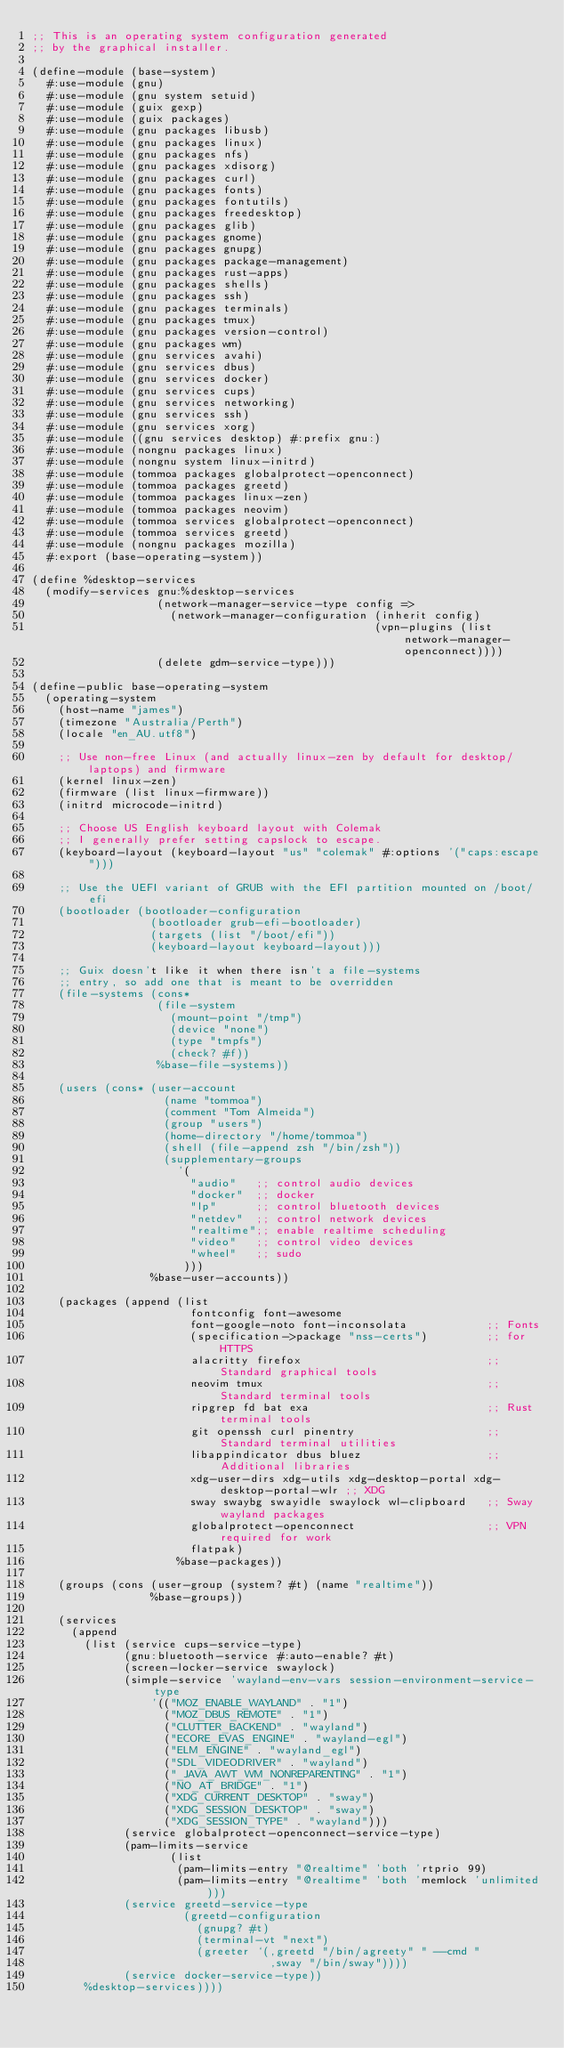Convert code to text. <code><loc_0><loc_0><loc_500><loc_500><_Scheme_>;; This is an operating system configuration generated
;; by the graphical installer.

(define-module (base-system)
  #:use-module (gnu)
  #:use-module (gnu system setuid)
  #:use-module (guix gexp)
  #:use-module (guix packages)
  #:use-module (gnu packages libusb)
  #:use-module (gnu packages linux)
  #:use-module (gnu packages nfs)
  #:use-module (gnu packages xdisorg)
  #:use-module (gnu packages curl)
  #:use-module (gnu packages fonts)
  #:use-module (gnu packages fontutils)
  #:use-module (gnu packages freedesktop)
  #:use-module (gnu packages glib)
  #:use-module (gnu packages gnome)
  #:use-module (gnu packages gnupg)
  #:use-module (gnu packages package-management)
  #:use-module (gnu packages rust-apps)
  #:use-module (gnu packages shells)
  #:use-module (gnu packages ssh)
  #:use-module (gnu packages terminals)
  #:use-module (gnu packages tmux)
  #:use-module (gnu packages version-control)
  #:use-module (gnu packages wm)
  #:use-module (gnu services avahi)
  #:use-module (gnu services dbus)
  #:use-module (gnu services docker)
  #:use-module (gnu services cups)
  #:use-module (gnu services networking)
  #:use-module (gnu services ssh)
  #:use-module (gnu services xorg)
  #:use-module ((gnu services desktop) #:prefix gnu:)
  #:use-module (nongnu packages linux)
  #:use-module (nongnu system linux-initrd)
  #:use-module (tommoa packages globalprotect-openconnect)
  #:use-module (tommoa packages greetd)
  #:use-module (tommoa packages linux-zen)
  #:use-module (tommoa packages neovim)
  #:use-module (tommoa services globalprotect-openconnect)
  #:use-module (tommoa services greetd)
  #:use-module (nongnu packages mozilla)
  #:export (base-operating-system))

(define %desktop-services
  (modify-services gnu:%desktop-services
                   (network-manager-service-type config =>
                     (network-manager-configuration (inherit config)
                                                    (vpn-plugins (list network-manager-openconnect))))
                   (delete gdm-service-type)))

(define-public base-operating-system
  (operating-system
    (host-name "james")
    (timezone "Australia/Perth")
    (locale "en_AU.utf8")

    ;; Use non-free Linux (and actually linux-zen by default for desktop/laptops) and firmware
    (kernel linux-zen)
    (firmware (list linux-firmware))
    (initrd microcode-initrd)

    ;; Choose US English keyboard layout with Colemak
    ;; I generally prefer setting capslock to escape.
    (keyboard-layout (keyboard-layout "us" "colemak" #:options '("caps:escape")))

    ;; Use the UEFI variant of GRUB with the EFI partition mounted on /boot/efi
    (bootloader (bootloader-configuration
                  (bootloader grub-efi-bootloader)
                  (targets (list "/boot/efi"))
                  (keyboard-layout keyboard-layout)))

    ;; Guix doesn't like it when there isn't a file-systems
    ;; entry, so add one that is meant to be overridden
    (file-systems (cons*
                   (file-system
                     (mount-point "/tmp")
                     (device "none")
                     (type "tmpfs")
                     (check? #f))
                   %base-file-systems))

    (users (cons* (user-account
                    (name "tommoa")
                    (comment "Tom Almeida")
                    (group "users")
                    (home-directory "/home/tommoa")
                    (shell (file-append zsh "/bin/zsh"))
                    (supplementary-groups
                      '(
                        "audio"   ;; control audio devices
                        "docker"  ;; docker
                        "lp"      ;; control bluetooth devices
                        "netdev"  ;; control network devices
                        "realtime";; enable realtime scheduling
                        "video"   ;; control video devices
                        "wheel"   ;; sudo
                       )))
                  %base-user-accounts))

    (packages (append (list
                        fontconfig font-awesome
                        font-google-noto font-inconsolata            ;; Fonts
                        (specification->package "nss-certs")         ;; for HTTPS
                        alacritty firefox                            ;; Standard graphical tools
                        neovim tmux                                  ;; Standard terminal tools
                        ripgrep fd bat exa                           ;; Rust terminal tools
                        git openssh curl pinentry                    ;; Standard terminal utilities
                        libappindicator dbus bluez                   ;; Additional libraries
                        xdg-user-dirs xdg-utils xdg-desktop-portal xdg-desktop-portal-wlr ;; XDG
                        sway swaybg swayidle swaylock wl-clipboard   ;; Sway wayland packages
                        globalprotect-openconnect                    ;; VPN required for work
                        flatpak)
                      %base-packages))

    (groups (cons (user-group (system? #t) (name "realtime"))
                  %base-groups))

    (services
      (append
        (list (service cups-service-type)
              (gnu:bluetooth-service #:auto-enable? #t)
              (screen-locker-service swaylock)
              (simple-service 'wayland-env-vars session-environment-service-type
                  '(("MOZ_ENABLE_WAYLAND" . "1")
                    ("MOZ_DBUS_REMOTE" . "1")
                    ("CLUTTER_BACKEND" . "wayland")
                    ("ECORE_EVAS_ENGINE" . "wayland-egl")
                    ("ELM_ENGINE" . "wayland_egl")
                    ("SDL_VIDEODRIVER" . "wayland")
                    ("_JAVA_AWT_WM_NONREPARENTING" . "1")
                    ("NO_AT_BRIDGE" . "1")
                    ("XDG_CURRENT_DESKTOP" . "sway")
                    ("XDG_SESSION_DESKTOP" . "sway")
                    ("XDG_SESSION_TYPE" . "wayland")))
              (service globalprotect-openconnect-service-type)
              (pam-limits-service
                     (list
                      (pam-limits-entry "@realtime" 'both 'rtprio 99)
                      (pam-limits-entry "@realtime" 'both 'memlock 'unlimited)))
              (service greetd-service-type
                       (greetd-configuration
                         (gnupg? #t)
                         (terminal-vt "next")
                         (greeter `(,greetd "/bin/agreety" " --cmd "
                                    ,sway "/bin/sway"))))
              (service docker-service-type))
        %desktop-services))))
</code> 